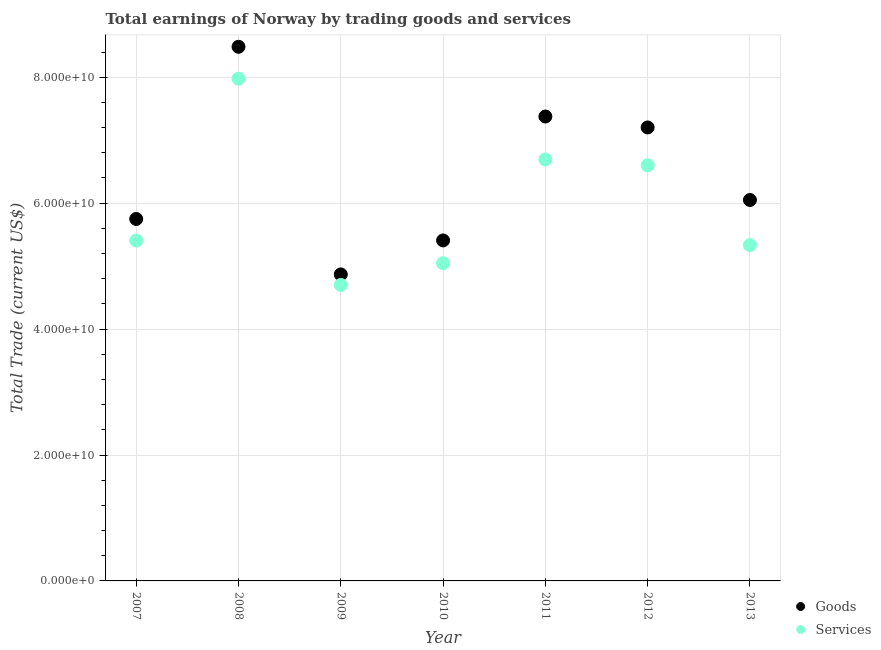How many different coloured dotlines are there?
Provide a short and direct response. 2. What is the amount earned by trading goods in 2013?
Offer a very short reply. 6.05e+1. Across all years, what is the maximum amount earned by trading goods?
Your answer should be very brief. 8.48e+1. Across all years, what is the minimum amount earned by trading goods?
Your answer should be compact. 4.87e+1. In which year was the amount earned by trading services minimum?
Your response must be concise. 2009. What is the total amount earned by trading goods in the graph?
Give a very brief answer. 4.51e+11. What is the difference between the amount earned by trading goods in 2007 and that in 2013?
Make the answer very short. -3.02e+09. What is the difference between the amount earned by trading goods in 2011 and the amount earned by trading services in 2010?
Give a very brief answer. 2.33e+1. What is the average amount earned by trading goods per year?
Ensure brevity in your answer.  6.45e+1. In the year 2013, what is the difference between the amount earned by trading goods and amount earned by trading services?
Provide a short and direct response. 7.17e+09. In how many years, is the amount earned by trading services greater than 68000000000 US$?
Your answer should be compact. 1. What is the ratio of the amount earned by trading services in 2009 to that in 2012?
Provide a succinct answer. 0.71. Is the difference between the amount earned by trading goods in 2010 and 2013 greater than the difference between the amount earned by trading services in 2010 and 2013?
Provide a succinct answer. No. What is the difference between the highest and the second highest amount earned by trading goods?
Your response must be concise. 1.11e+1. What is the difference between the highest and the lowest amount earned by trading goods?
Give a very brief answer. 3.62e+1. Is the sum of the amount earned by trading services in 2010 and 2011 greater than the maximum amount earned by trading goods across all years?
Provide a short and direct response. Yes. Does the amount earned by trading services monotonically increase over the years?
Your answer should be very brief. No. Is the amount earned by trading goods strictly less than the amount earned by trading services over the years?
Your answer should be compact. No. Does the graph contain any zero values?
Provide a short and direct response. No. Does the graph contain grids?
Make the answer very short. Yes. What is the title of the graph?
Ensure brevity in your answer.  Total earnings of Norway by trading goods and services. What is the label or title of the Y-axis?
Give a very brief answer. Total Trade (current US$). What is the Total Trade (current US$) of Goods in 2007?
Keep it short and to the point. 5.75e+1. What is the Total Trade (current US$) of Services in 2007?
Keep it short and to the point. 5.41e+1. What is the Total Trade (current US$) of Goods in 2008?
Your answer should be very brief. 8.48e+1. What is the Total Trade (current US$) in Services in 2008?
Make the answer very short. 7.98e+1. What is the Total Trade (current US$) of Goods in 2009?
Ensure brevity in your answer.  4.87e+1. What is the Total Trade (current US$) of Services in 2009?
Provide a short and direct response. 4.70e+1. What is the Total Trade (current US$) of Goods in 2010?
Your answer should be very brief. 5.41e+1. What is the Total Trade (current US$) in Services in 2010?
Ensure brevity in your answer.  5.05e+1. What is the Total Trade (current US$) of Goods in 2011?
Give a very brief answer. 7.38e+1. What is the Total Trade (current US$) of Services in 2011?
Your response must be concise. 6.69e+1. What is the Total Trade (current US$) in Goods in 2012?
Provide a short and direct response. 7.20e+1. What is the Total Trade (current US$) of Services in 2012?
Offer a very short reply. 6.60e+1. What is the Total Trade (current US$) in Goods in 2013?
Your answer should be compact. 6.05e+1. What is the Total Trade (current US$) in Services in 2013?
Offer a very short reply. 5.33e+1. Across all years, what is the maximum Total Trade (current US$) of Goods?
Ensure brevity in your answer.  8.48e+1. Across all years, what is the maximum Total Trade (current US$) of Services?
Provide a short and direct response. 7.98e+1. Across all years, what is the minimum Total Trade (current US$) of Goods?
Make the answer very short. 4.87e+1. Across all years, what is the minimum Total Trade (current US$) in Services?
Make the answer very short. 4.70e+1. What is the total Total Trade (current US$) of Goods in the graph?
Offer a terse response. 4.51e+11. What is the total Total Trade (current US$) in Services in the graph?
Your answer should be compact. 4.18e+11. What is the difference between the Total Trade (current US$) of Goods in 2007 and that in 2008?
Your response must be concise. -2.74e+1. What is the difference between the Total Trade (current US$) in Services in 2007 and that in 2008?
Offer a terse response. -2.57e+1. What is the difference between the Total Trade (current US$) in Goods in 2007 and that in 2009?
Offer a very short reply. 8.80e+09. What is the difference between the Total Trade (current US$) of Services in 2007 and that in 2009?
Provide a succinct answer. 7.04e+09. What is the difference between the Total Trade (current US$) in Goods in 2007 and that in 2010?
Offer a very short reply. 3.41e+09. What is the difference between the Total Trade (current US$) of Services in 2007 and that in 2010?
Your answer should be compact. 3.59e+09. What is the difference between the Total Trade (current US$) of Goods in 2007 and that in 2011?
Provide a short and direct response. -1.63e+1. What is the difference between the Total Trade (current US$) of Services in 2007 and that in 2011?
Keep it short and to the point. -1.29e+1. What is the difference between the Total Trade (current US$) in Goods in 2007 and that in 2012?
Make the answer very short. -1.45e+1. What is the difference between the Total Trade (current US$) of Services in 2007 and that in 2012?
Offer a terse response. -1.20e+1. What is the difference between the Total Trade (current US$) of Goods in 2007 and that in 2013?
Give a very brief answer. -3.02e+09. What is the difference between the Total Trade (current US$) in Services in 2007 and that in 2013?
Your answer should be very brief. 7.18e+08. What is the difference between the Total Trade (current US$) of Goods in 2008 and that in 2009?
Your answer should be very brief. 3.62e+1. What is the difference between the Total Trade (current US$) of Services in 2008 and that in 2009?
Offer a very short reply. 3.28e+1. What is the difference between the Total Trade (current US$) in Goods in 2008 and that in 2010?
Ensure brevity in your answer.  3.08e+1. What is the difference between the Total Trade (current US$) in Services in 2008 and that in 2010?
Offer a terse response. 2.93e+1. What is the difference between the Total Trade (current US$) in Goods in 2008 and that in 2011?
Offer a very short reply. 1.11e+1. What is the difference between the Total Trade (current US$) of Services in 2008 and that in 2011?
Keep it short and to the point. 1.28e+1. What is the difference between the Total Trade (current US$) in Goods in 2008 and that in 2012?
Offer a terse response. 1.28e+1. What is the difference between the Total Trade (current US$) in Services in 2008 and that in 2012?
Offer a terse response. 1.38e+1. What is the difference between the Total Trade (current US$) in Goods in 2008 and that in 2013?
Your response must be concise. 2.43e+1. What is the difference between the Total Trade (current US$) of Services in 2008 and that in 2013?
Make the answer very short. 2.64e+1. What is the difference between the Total Trade (current US$) in Goods in 2009 and that in 2010?
Give a very brief answer. -5.40e+09. What is the difference between the Total Trade (current US$) in Services in 2009 and that in 2010?
Your response must be concise. -3.45e+09. What is the difference between the Total Trade (current US$) of Goods in 2009 and that in 2011?
Your response must be concise. -2.51e+1. What is the difference between the Total Trade (current US$) in Services in 2009 and that in 2011?
Make the answer very short. -1.99e+1. What is the difference between the Total Trade (current US$) in Goods in 2009 and that in 2012?
Keep it short and to the point. -2.33e+1. What is the difference between the Total Trade (current US$) of Services in 2009 and that in 2012?
Your answer should be compact. -1.90e+1. What is the difference between the Total Trade (current US$) in Goods in 2009 and that in 2013?
Offer a very short reply. -1.18e+1. What is the difference between the Total Trade (current US$) of Services in 2009 and that in 2013?
Provide a succinct answer. -6.32e+09. What is the difference between the Total Trade (current US$) in Goods in 2010 and that in 2011?
Offer a terse response. -1.97e+1. What is the difference between the Total Trade (current US$) of Services in 2010 and that in 2011?
Provide a succinct answer. -1.65e+1. What is the difference between the Total Trade (current US$) of Goods in 2010 and that in 2012?
Give a very brief answer. -1.79e+1. What is the difference between the Total Trade (current US$) of Services in 2010 and that in 2012?
Your answer should be compact. -1.55e+1. What is the difference between the Total Trade (current US$) of Goods in 2010 and that in 2013?
Offer a terse response. -6.43e+09. What is the difference between the Total Trade (current US$) of Services in 2010 and that in 2013?
Offer a very short reply. -2.87e+09. What is the difference between the Total Trade (current US$) of Goods in 2011 and that in 2012?
Provide a short and direct response. 1.74e+09. What is the difference between the Total Trade (current US$) in Services in 2011 and that in 2012?
Your answer should be compact. 9.37e+08. What is the difference between the Total Trade (current US$) of Goods in 2011 and that in 2013?
Your answer should be compact. 1.33e+1. What is the difference between the Total Trade (current US$) in Services in 2011 and that in 2013?
Your answer should be compact. 1.36e+1. What is the difference between the Total Trade (current US$) of Goods in 2012 and that in 2013?
Give a very brief answer. 1.15e+1. What is the difference between the Total Trade (current US$) in Services in 2012 and that in 2013?
Provide a short and direct response. 1.27e+1. What is the difference between the Total Trade (current US$) of Goods in 2007 and the Total Trade (current US$) of Services in 2008?
Make the answer very short. -2.23e+1. What is the difference between the Total Trade (current US$) in Goods in 2007 and the Total Trade (current US$) in Services in 2009?
Provide a short and direct response. 1.05e+1. What is the difference between the Total Trade (current US$) of Goods in 2007 and the Total Trade (current US$) of Services in 2010?
Make the answer very short. 7.03e+09. What is the difference between the Total Trade (current US$) of Goods in 2007 and the Total Trade (current US$) of Services in 2011?
Keep it short and to the point. -9.46e+09. What is the difference between the Total Trade (current US$) of Goods in 2007 and the Total Trade (current US$) of Services in 2012?
Your answer should be compact. -8.52e+09. What is the difference between the Total Trade (current US$) of Goods in 2007 and the Total Trade (current US$) of Services in 2013?
Provide a short and direct response. 4.15e+09. What is the difference between the Total Trade (current US$) of Goods in 2008 and the Total Trade (current US$) of Services in 2009?
Make the answer very short. 3.78e+1. What is the difference between the Total Trade (current US$) in Goods in 2008 and the Total Trade (current US$) in Services in 2010?
Provide a succinct answer. 3.44e+1. What is the difference between the Total Trade (current US$) in Goods in 2008 and the Total Trade (current US$) in Services in 2011?
Your answer should be very brief. 1.79e+1. What is the difference between the Total Trade (current US$) in Goods in 2008 and the Total Trade (current US$) in Services in 2012?
Ensure brevity in your answer.  1.88e+1. What is the difference between the Total Trade (current US$) in Goods in 2008 and the Total Trade (current US$) in Services in 2013?
Give a very brief answer. 3.15e+1. What is the difference between the Total Trade (current US$) of Goods in 2009 and the Total Trade (current US$) of Services in 2010?
Keep it short and to the point. -1.78e+09. What is the difference between the Total Trade (current US$) in Goods in 2009 and the Total Trade (current US$) in Services in 2011?
Make the answer very short. -1.83e+1. What is the difference between the Total Trade (current US$) of Goods in 2009 and the Total Trade (current US$) of Services in 2012?
Offer a terse response. -1.73e+1. What is the difference between the Total Trade (current US$) of Goods in 2009 and the Total Trade (current US$) of Services in 2013?
Offer a very short reply. -4.65e+09. What is the difference between the Total Trade (current US$) of Goods in 2010 and the Total Trade (current US$) of Services in 2011?
Your answer should be compact. -1.29e+1. What is the difference between the Total Trade (current US$) in Goods in 2010 and the Total Trade (current US$) in Services in 2012?
Keep it short and to the point. -1.19e+1. What is the difference between the Total Trade (current US$) in Goods in 2010 and the Total Trade (current US$) in Services in 2013?
Offer a terse response. 7.48e+08. What is the difference between the Total Trade (current US$) in Goods in 2011 and the Total Trade (current US$) in Services in 2012?
Your response must be concise. 7.75e+09. What is the difference between the Total Trade (current US$) in Goods in 2011 and the Total Trade (current US$) in Services in 2013?
Ensure brevity in your answer.  2.04e+1. What is the difference between the Total Trade (current US$) of Goods in 2012 and the Total Trade (current US$) of Services in 2013?
Provide a succinct answer. 1.87e+1. What is the average Total Trade (current US$) of Goods per year?
Offer a very short reply. 6.45e+1. What is the average Total Trade (current US$) of Services per year?
Provide a short and direct response. 5.97e+1. In the year 2007, what is the difference between the Total Trade (current US$) in Goods and Total Trade (current US$) in Services?
Make the answer very short. 3.44e+09. In the year 2008, what is the difference between the Total Trade (current US$) of Goods and Total Trade (current US$) of Services?
Your response must be concise. 5.07e+09. In the year 2009, what is the difference between the Total Trade (current US$) in Goods and Total Trade (current US$) in Services?
Provide a succinct answer. 1.68e+09. In the year 2010, what is the difference between the Total Trade (current US$) of Goods and Total Trade (current US$) of Services?
Ensure brevity in your answer.  3.62e+09. In the year 2011, what is the difference between the Total Trade (current US$) in Goods and Total Trade (current US$) in Services?
Your response must be concise. 6.82e+09. In the year 2012, what is the difference between the Total Trade (current US$) in Goods and Total Trade (current US$) in Services?
Your response must be concise. 6.02e+09. In the year 2013, what is the difference between the Total Trade (current US$) of Goods and Total Trade (current US$) of Services?
Provide a short and direct response. 7.17e+09. What is the ratio of the Total Trade (current US$) of Goods in 2007 to that in 2008?
Keep it short and to the point. 0.68. What is the ratio of the Total Trade (current US$) in Services in 2007 to that in 2008?
Provide a short and direct response. 0.68. What is the ratio of the Total Trade (current US$) in Goods in 2007 to that in 2009?
Ensure brevity in your answer.  1.18. What is the ratio of the Total Trade (current US$) of Services in 2007 to that in 2009?
Keep it short and to the point. 1.15. What is the ratio of the Total Trade (current US$) of Goods in 2007 to that in 2010?
Keep it short and to the point. 1.06. What is the ratio of the Total Trade (current US$) of Services in 2007 to that in 2010?
Offer a very short reply. 1.07. What is the ratio of the Total Trade (current US$) in Goods in 2007 to that in 2011?
Give a very brief answer. 0.78. What is the ratio of the Total Trade (current US$) in Services in 2007 to that in 2011?
Your answer should be very brief. 0.81. What is the ratio of the Total Trade (current US$) of Goods in 2007 to that in 2012?
Give a very brief answer. 0.8. What is the ratio of the Total Trade (current US$) of Services in 2007 to that in 2012?
Your answer should be compact. 0.82. What is the ratio of the Total Trade (current US$) in Goods in 2007 to that in 2013?
Ensure brevity in your answer.  0.95. What is the ratio of the Total Trade (current US$) of Services in 2007 to that in 2013?
Provide a short and direct response. 1.01. What is the ratio of the Total Trade (current US$) in Goods in 2008 to that in 2009?
Ensure brevity in your answer.  1.74. What is the ratio of the Total Trade (current US$) in Services in 2008 to that in 2009?
Your answer should be very brief. 1.7. What is the ratio of the Total Trade (current US$) in Goods in 2008 to that in 2010?
Keep it short and to the point. 1.57. What is the ratio of the Total Trade (current US$) in Services in 2008 to that in 2010?
Your response must be concise. 1.58. What is the ratio of the Total Trade (current US$) of Goods in 2008 to that in 2011?
Offer a terse response. 1.15. What is the ratio of the Total Trade (current US$) in Services in 2008 to that in 2011?
Make the answer very short. 1.19. What is the ratio of the Total Trade (current US$) in Goods in 2008 to that in 2012?
Keep it short and to the point. 1.18. What is the ratio of the Total Trade (current US$) in Services in 2008 to that in 2012?
Ensure brevity in your answer.  1.21. What is the ratio of the Total Trade (current US$) of Goods in 2008 to that in 2013?
Provide a short and direct response. 1.4. What is the ratio of the Total Trade (current US$) in Services in 2008 to that in 2013?
Provide a short and direct response. 1.5. What is the ratio of the Total Trade (current US$) of Goods in 2009 to that in 2010?
Provide a short and direct response. 0.9. What is the ratio of the Total Trade (current US$) in Services in 2009 to that in 2010?
Offer a terse response. 0.93. What is the ratio of the Total Trade (current US$) of Goods in 2009 to that in 2011?
Provide a short and direct response. 0.66. What is the ratio of the Total Trade (current US$) of Services in 2009 to that in 2011?
Keep it short and to the point. 0.7. What is the ratio of the Total Trade (current US$) in Goods in 2009 to that in 2012?
Keep it short and to the point. 0.68. What is the ratio of the Total Trade (current US$) of Services in 2009 to that in 2012?
Your answer should be compact. 0.71. What is the ratio of the Total Trade (current US$) in Goods in 2009 to that in 2013?
Ensure brevity in your answer.  0.8. What is the ratio of the Total Trade (current US$) in Services in 2009 to that in 2013?
Your answer should be very brief. 0.88. What is the ratio of the Total Trade (current US$) in Goods in 2010 to that in 2011?
Offer a very short reply. 0.73. What is the ratio of the Total Trade (current US$) of Services in 2010 to that in 2011?
Provide a short and direct response. 0.75. What is the ratio of the Total Trade (current US$) in Goods in 2010 to that in 2012?
Provide a short and direct response. 0.75. What is the ratio of the Total Trade (current US$) of Services in 2010 to that in 2012?
Your response must be concise. 0.76. What is the ratio of the Total Trade (current US$) of Goods in 2010 to that in 2013?
Ensure brevity in your answer.  0.89. What is the ratio of the Total Trade (current US$) in Services in 2010 to that in 2013?
Your answer should be very brief. 0.95. What is the ratio of the Total Trade (current US$) in Goods in 2011 to that in 2012?
Provide a succinct answer. 1.02. What is the ratio of the Total Trade (current US$) of Services in 2011 to that in 2012?
Your answer should be very brief. 1.01. What is the ratio of the Total Trade (current US$) of Goods in 2011 to that in 2013?
Your answer should be very brief. 1.22. What is the ratio of the Total Trade (current US$) of Services in 2011 to that in 2013?
Offer a very short reply. 1.26. What is the ratio of the Total Trade (current US$) in Goods in 2012 to that in 2013?
Your answer should be very brief. 1.19. What is the ratio of the Total Trade (current US$) of Services in 2012 to that in 2013?
Your response must be concise. 1.24. What is the difference between the highest and the second highest Total Trade (current US$) in Goods?
Keep it short and to the point. 1.11e+1. What is the difference between the highest and the second highest Total Trade (current US$) of Services?
Make the answer very short. 1.28e+1. What is the difference between the highest and the lowest Total Trade (current US$) of Goods?
Your answer should be compact. 3.62e+1. What is the difference between the highest and the lowest Total Trade (current US$) in Services?
Offer a very short reply. 3.28e+1. 